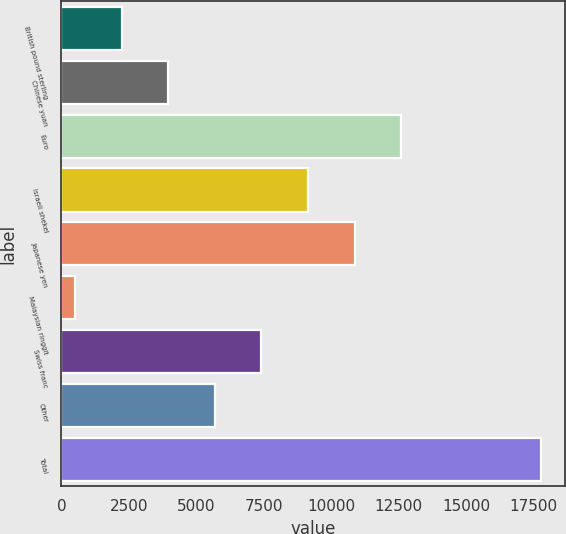Convert chart. <chart><loc_0><loc_0><loc_500><loc_500><bar_chart><fcel>British pound sterling<fcel>Chinese yuan<fcel>Euro<fcel>Israeli shekel<fcel>Japanese yen<fcel>Malaysian ringgit<fcel>Swiss franc<fcel>Other<fcel>Total<nl><fcel>2233.5<fcel>3961<fcel>12598.5<fcel>9143.5<fcel>10871<fcel>506<fcel>7416<fcel>5688.5<fcel>17781<nl></chart> 